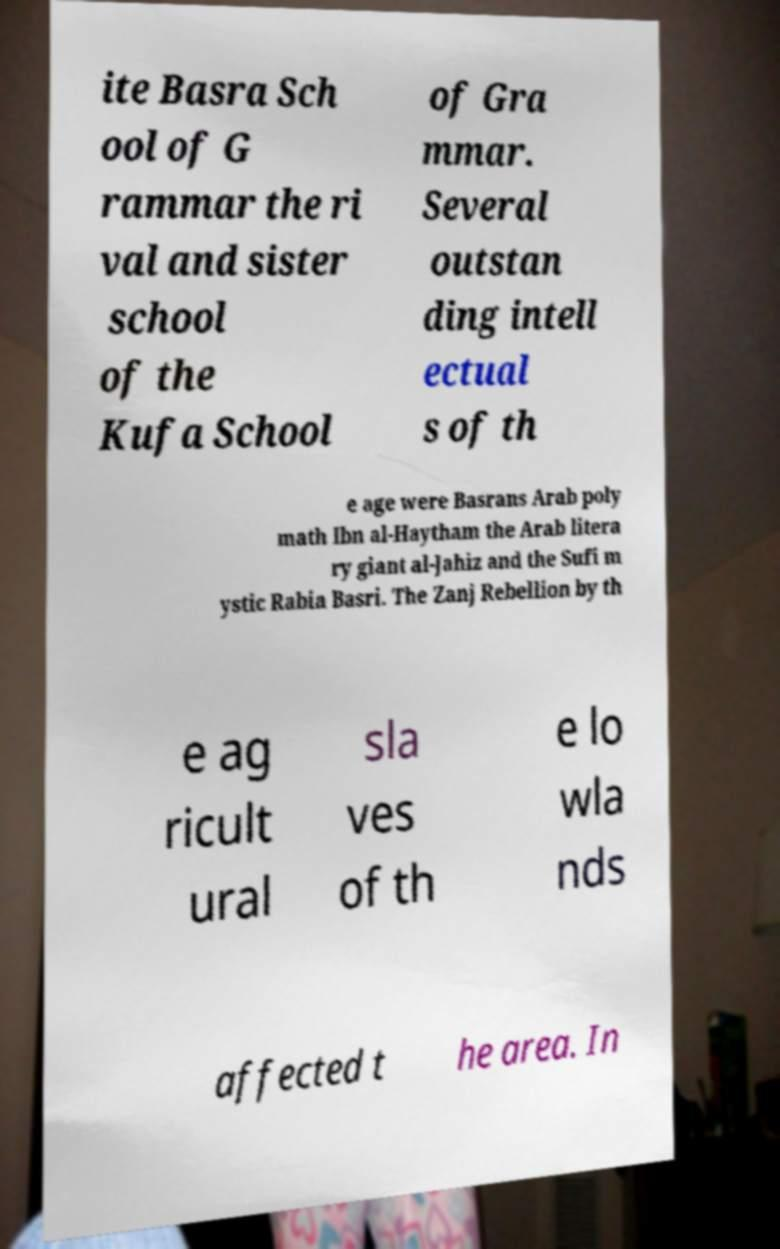Can you read and provide the text displayed in the image?This photo seems to have some interesting text. Can you extract and type it out for me? ite Basra Sch ool of G rammar the ri val and sister school of the Kufa School of Gra mmar. Several outstan ding intell ectual s of th e age were Basrans Arab poly math Ibn al-Haytham the Arab litera ry giant al-Jahiz and the Sufi m ystic Rabia Basri. The Zanj Rebellion by th e ag ricult ural sla ves of th e lo wla nds affected t he area. In 